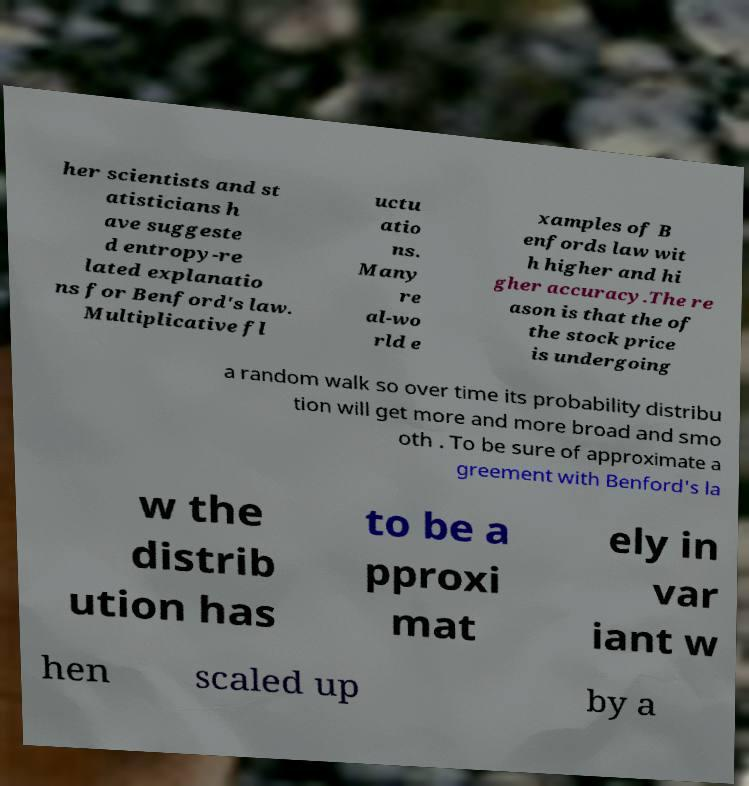Could you extract and type out the text from this image? her scientists and st atisticians h ave suggeste d entropy-re lated explanatio ns for Benford's law. Multiplicative fl uctu atio ns. Many re al-wo rld e xamples of B enfords law wit h higher and hi gher accuracy.The re ason is that the of the stock price is undergoing a random walk so over time its probability distribu tion will get more and more broad and smo oth . To be sure of approximate a greement with Benford's la w the distrib ution has to be a pproxi mat ely in var iant w hen scaled up by a 